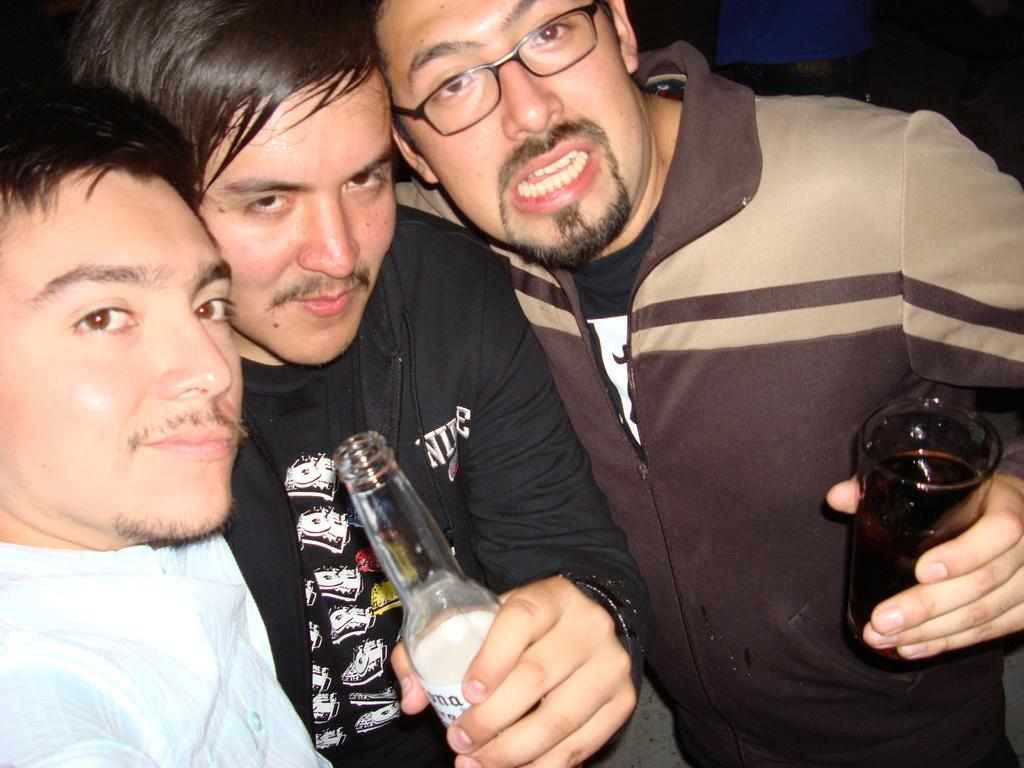What is the person on the right side of the image holding? The person on the right is holding a glass of drink. Who is standing beside the person on the right? We start by identifying the main subjects in the image, which are the three people. We then describe what each person is holding, as well as their relative positions to one another. Each question is designed to elicit a specific detail about the image that is known from the provided facts. Absurd Question/Answer: What type of instrument is the clam playing in the image? There is no clam or instrument present in the image. How many cats are sitting on the person on the right's shoulder in the image? There are no cats present in the image. What type of clam is visible in the image? There is no clam present in the image. 